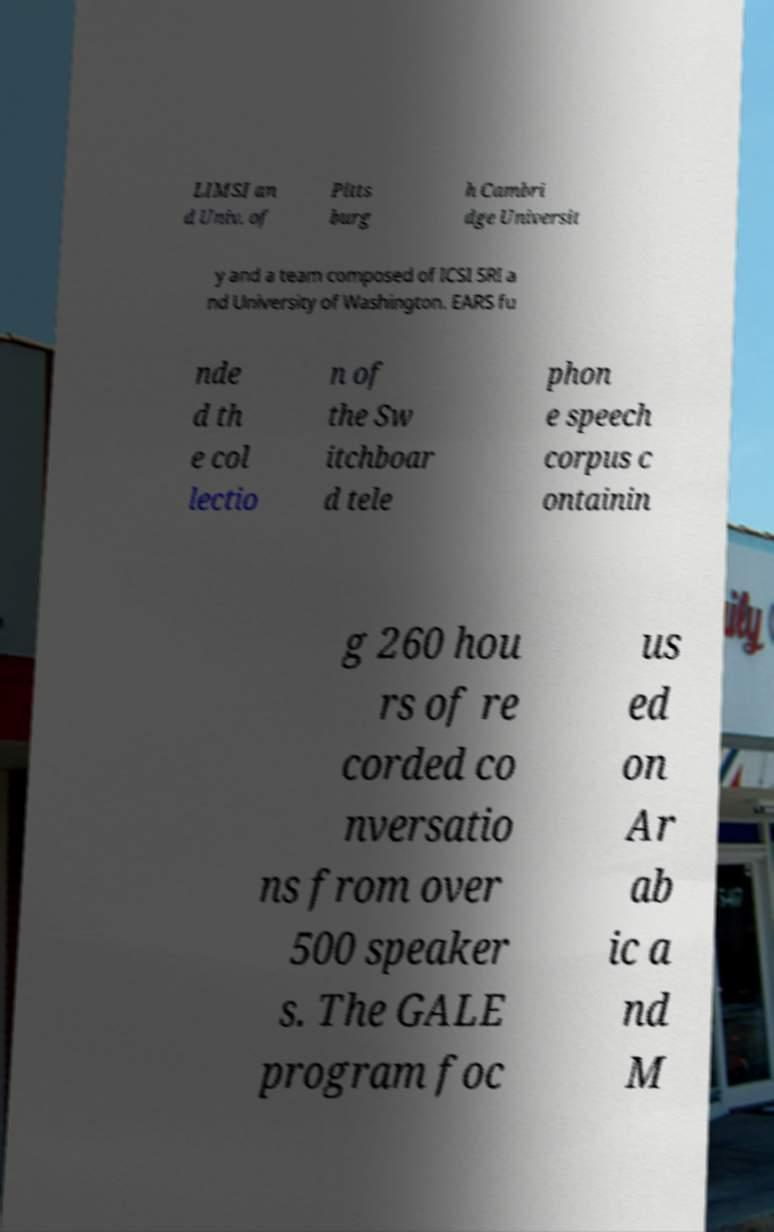I need the written content from this picture converted into text. Can you do that? LIMSI an d Univ. of Pitts burg h Cambri dge Universit y and a team composed of ICSI SRI a nd University of Washington. EARS fu nde d th e col lectio n of the Sw itchboar d tele phon e speech corpus c ontainin g 260 hou rs of re corded co nversatio ns from over 500 speaker s. The GALE program foc us ed on Ar ab ic a nd M 